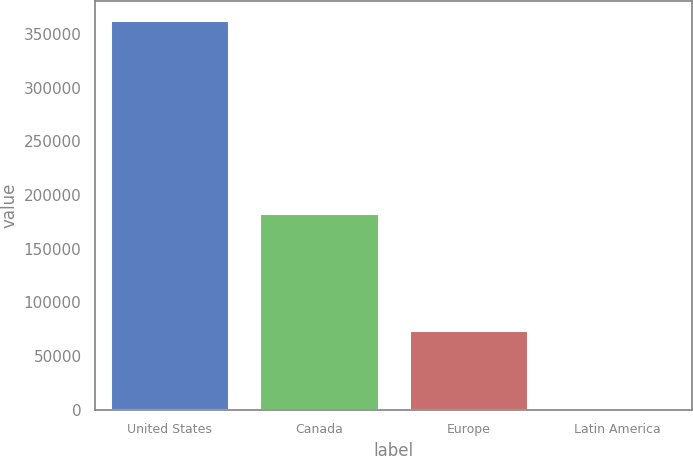Convert chart. <chart><loc_0><loc_0><loc_500><loc_500><bar_chart><fcel>United States<fcel>Canada<fcel>Europe<fcel>Latin America<nl><fcel>362982<fcel>183219<fcel>74214<fcel>1737<nl></chart> 